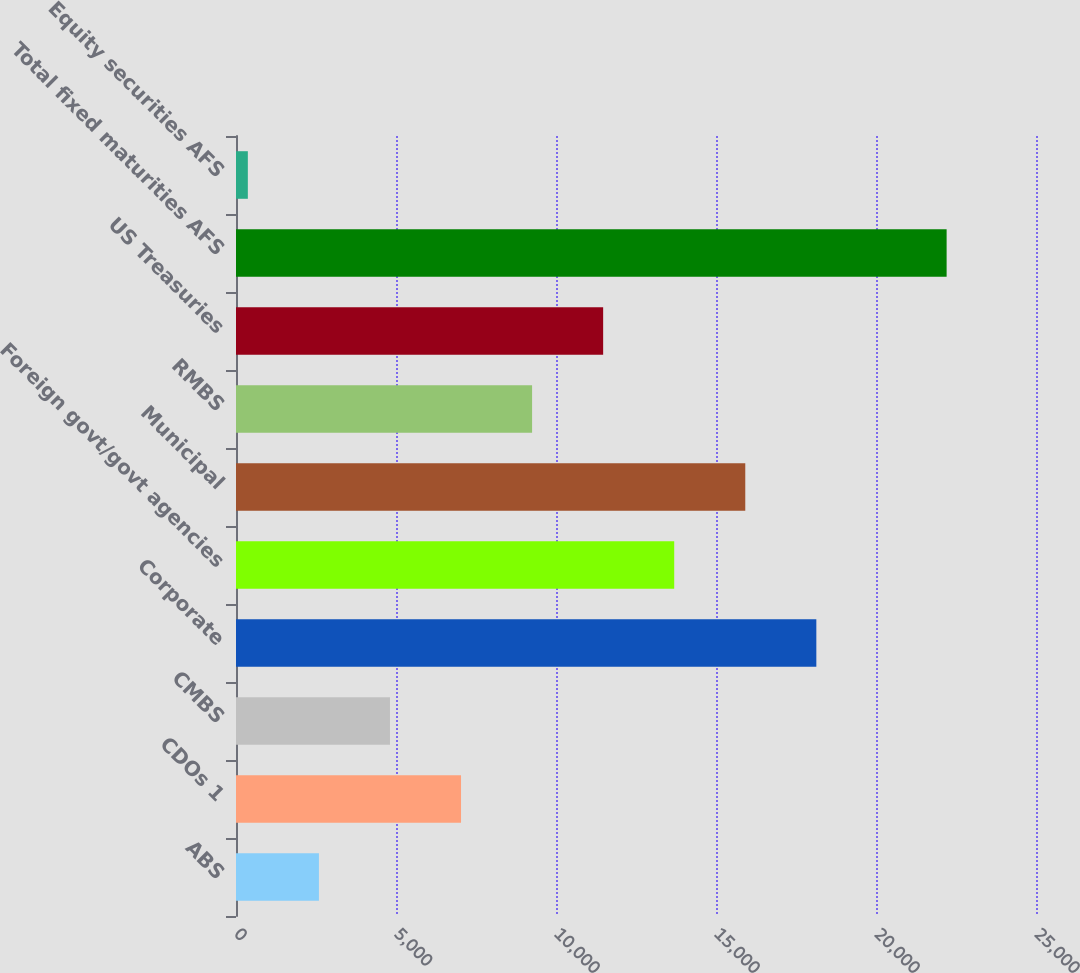Convert chart to OTSL. <chart><loc_0><loc_0><loc_500><loc_500><bar_chart><fcel>ABS<fcel>CDOs 1<fcel>CMBS<fcel>Corporate<fcel>Foreign govt/govt agencies<fcel>Municipal<fcel>RMBS<fcel>US Treasuries<fcel>Total fixed maturities AFS<fcel>Equity securities AFS<nl><fcel>2590.7<fcel>7032.1<fcel>4811.4<fcel>18135.6<fcel>13694.2<fcel>15914.9<fcel>9252.8<fcel>11473.5<fcel>22207<fcel>370<nl></chart> 